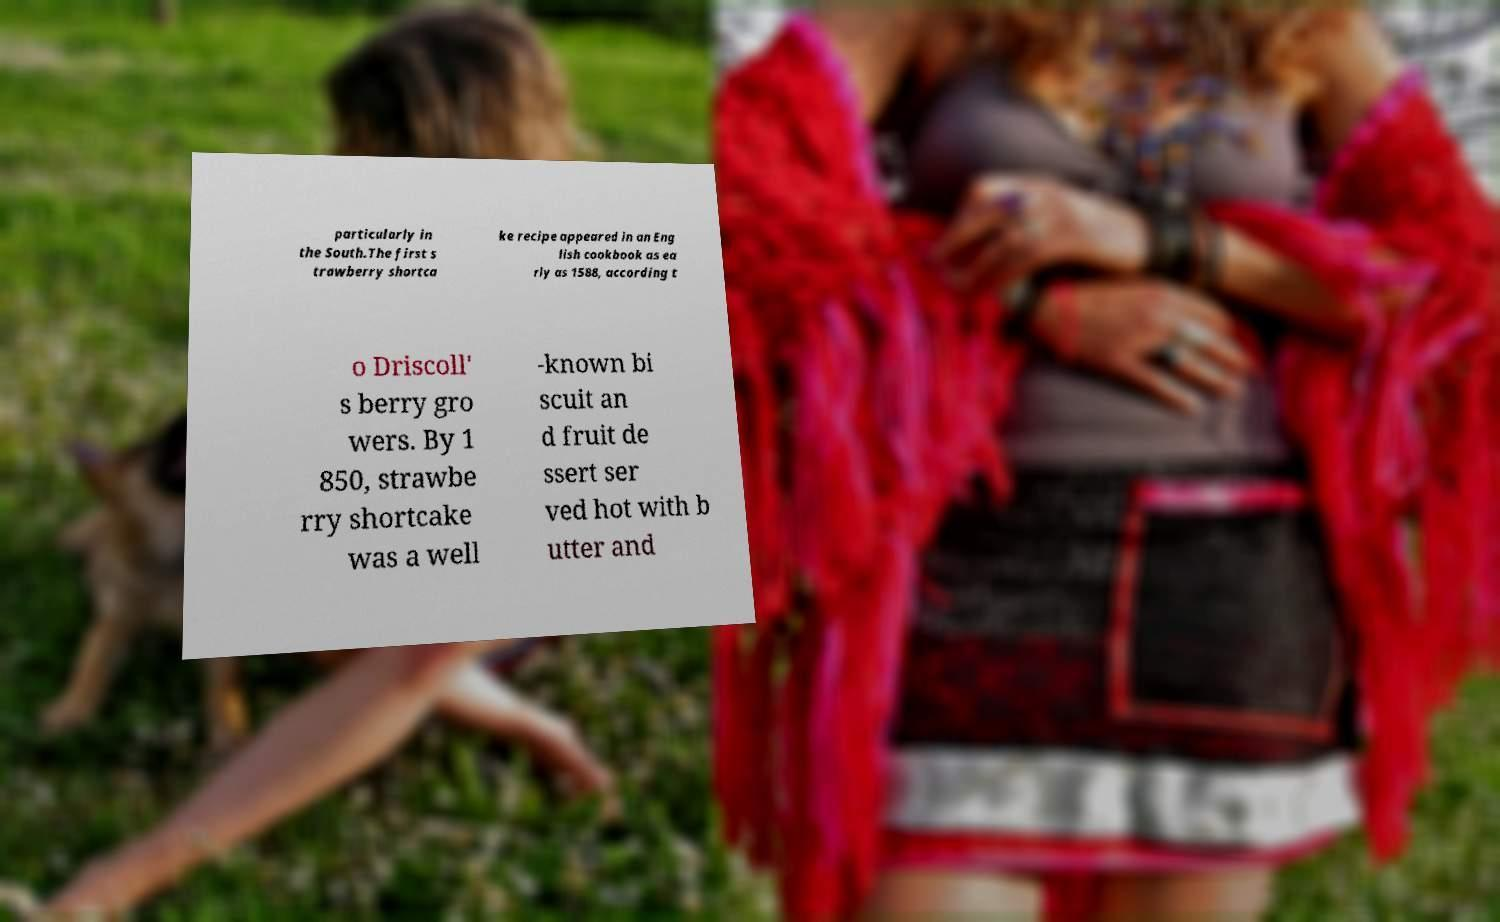Could you extract and type out the text from this image? particularly in the South.The first s trawberry shortca ke recipe appeared in an Eng lish cookbook as ea rly as 1588, according t o Driscoll' s berry gro wers. By 1 850, strawbe rry shortcake was a well -known bi scuit an d fruit de ssert ser ved hot with b utter and 